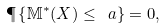Convert formula to latex. <formula><loc_0><loc_0><loc_500><loc_500>\P \left \{ \mathbb { M } ^ { * } ( X ) \leq \ a \right \} = 0 ,</formula> 